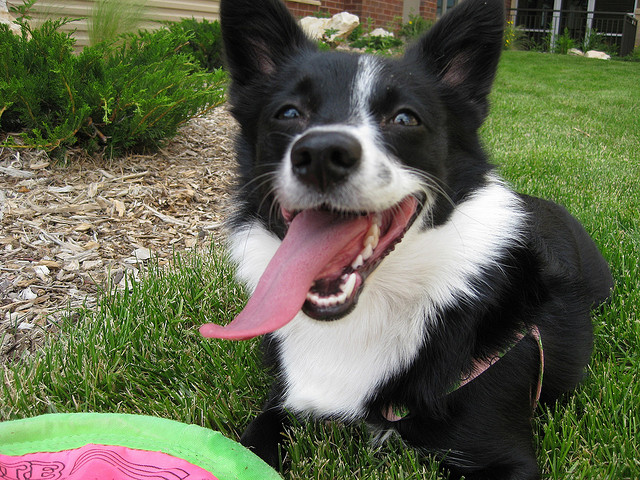<image>What color is the dog's collar? I don't know what color the dog's collar is. It can be pink, green, multi color or brown. It could also be that the dog is not wearing a collar. What color is the dog's collar? It is ambiguous what color is the dog's collar. It can be seen pink, brown or multi color. 